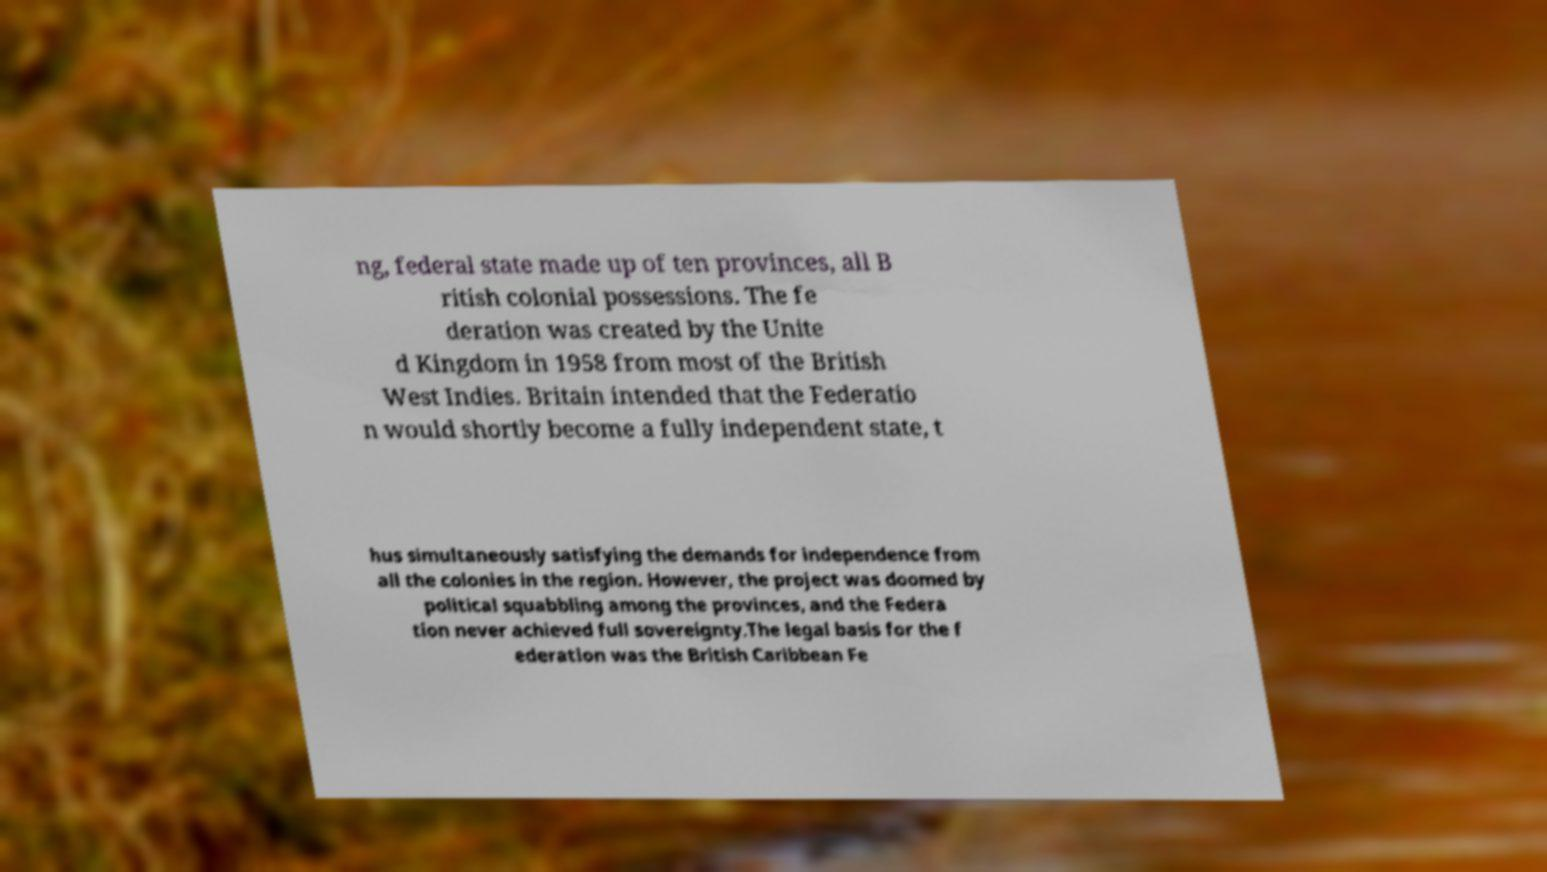For documentation purposes, I need the text within this image transcribed. Could you provide that? ng, federal state made up of ten provinces, all B ritish colonial possessions. The fe deration was created by the Unite d Kingdom in 1958 from most of the British West Indies. Britain intended that the Federatio n would shortly become a fully independent state, t hus simultaneously satisfying the demands for independence from all the colonies in the region. However, the project was doomed by political squabbling among the provinces, and the Federa tion never achieved full sovereignty.The legal basis for the f ederation was the British Caribbean Fe 